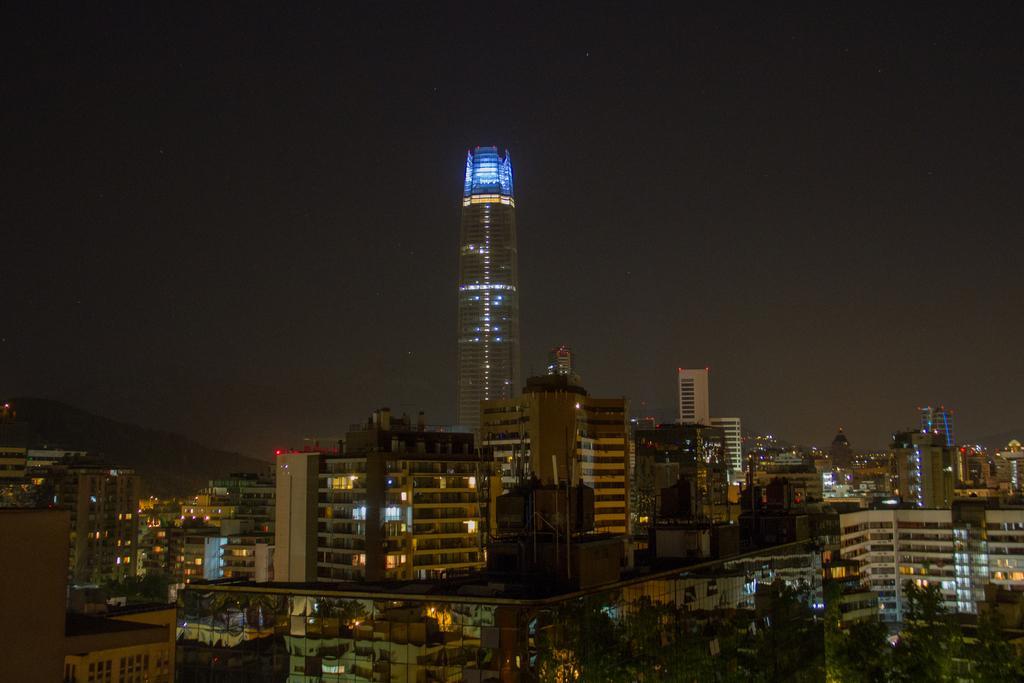How would you summarize this image in a sentence or two? In the image we can see there are buildings and trees. This is a tower, lights and a pale dark sky. 